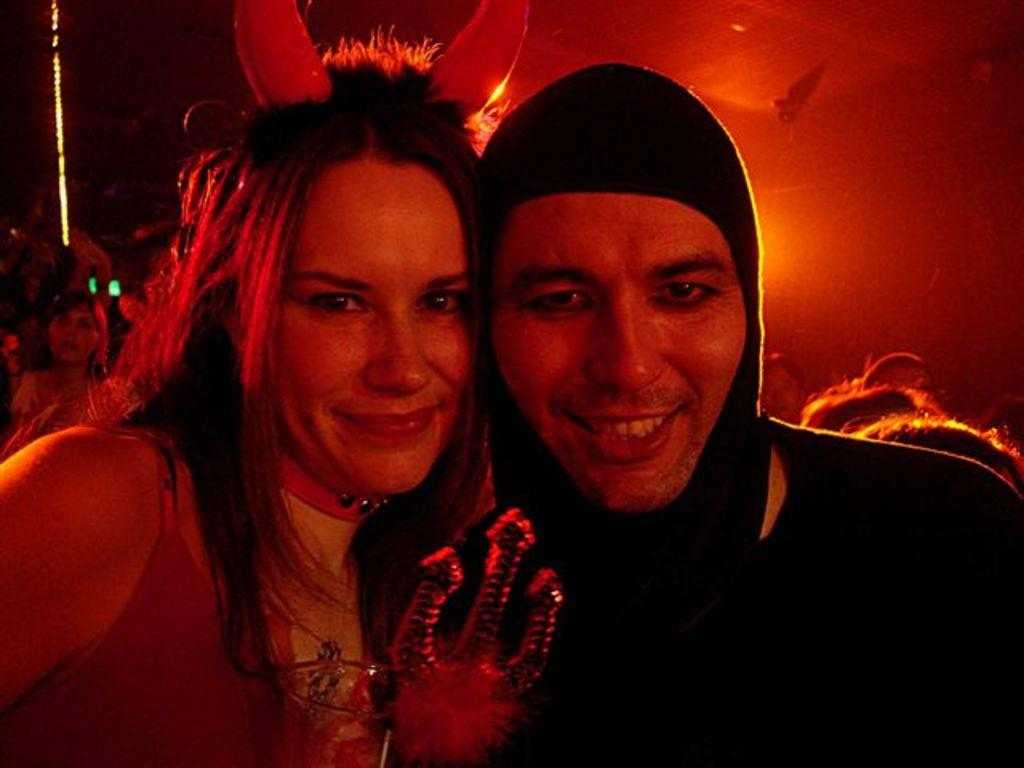Who or what is present in the image? There are people in the image. What can be observed about the people's attire? The people are wearing different color dresses. What color light is visible in the image? There is a red color light visible in the image. What type of glove is being used by the person in the image? There is no glove visible in the image. What angle is the person in the image standing at? The angle at which the person is standing cannot be determined from the image. 